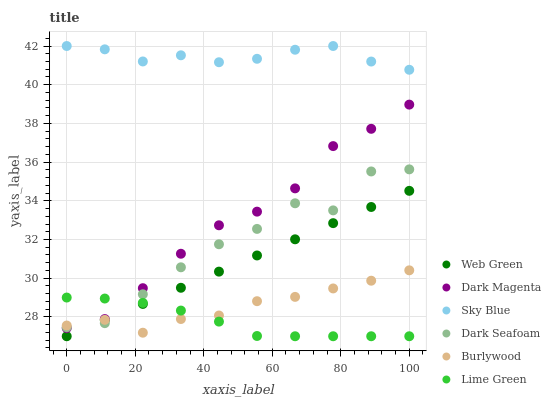Does Lime Green have the minimum area under the curve?
Answer yes or no. Yes. Does Sky Blue have the maximum area under the curve?
Answer yes or no. Yes. Does Burlywood have the minimum area under the curve?
Answer yes or no. No. Does Burlywood have the maximum area under the curve?
Answer yes or no. No. Is Web Green the smoothest?
Answer yes or no. Yes. Is Dark Seafoam the roughest?
Answer yes or no. Yes. Is Burlywood the smoothest?
Answer yes or no. No. Is Burlywood the roughest?
Answer yes or no. No. Does Web Green have the lowest value?
Answer yes or no. Yes. Does Burlywood have the lowest value?
Answer yes or no. No. Does Sky Blue have the highest value?
Answer yes or no. Yes. Does Burlywood have the highest value?
Answer yes or no. No. Is Web Green less than Sky Blue?
Answer yes or no. Yes. Is Sky Blue greater than Burlywood?
Answer yes or no. Yes. Does Dark Seafoam intersect Dark Magenta?
Answer yes or no. Yes. Is Dark Seafoam less than Dark Magenta?
Answer yes or no. No. Is Dark Seafoam greater than Dark Magenta?
Answer yes or no. No. Does Web Green intersect Sky Blue?
Answer yes or no. No. 